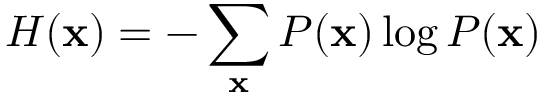Convert formula to latex. <formula><loc_0><loc_0><loc_500><loc_500>H ( x ) = - \sum _ { x } P ( x ) \log P ( x )</formula> 